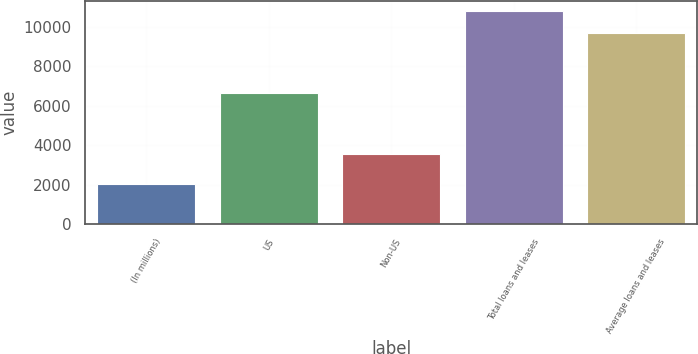Convert chart. <chart><loc_0><loc_0><loc_500><loc_500><bar_chart><fcel>(In millions)<fcel>US<fcel>Non-US<fcel>Total loans and leases<fcel>Average loans and leases<nl><fcel>2009<fcel>6637<fcel>3571<fcel>10808<fcel>9703<nl></chart> 